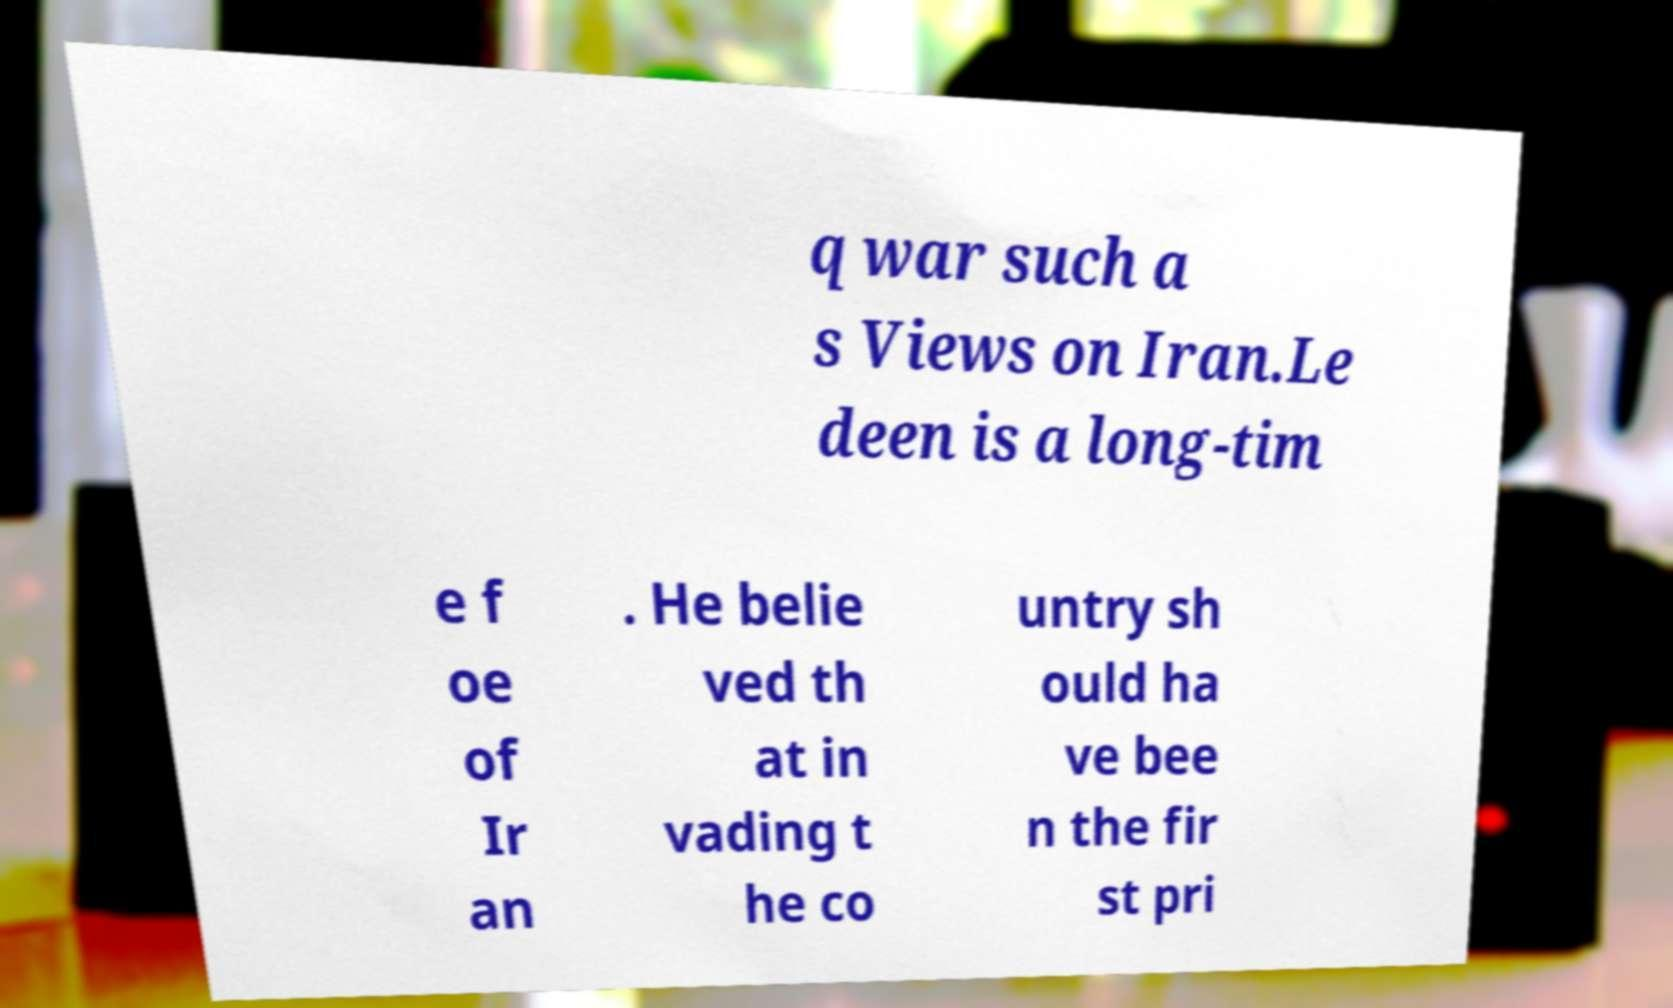For documentation purposes, I need the text within this image transcribed. Could you provide that? q war such a s Views on Iran.Le deen is a long-tim e f oe of Ir an . He belie ved th at in vading t he co untry sh ould ha ve bee n the fir st pri 